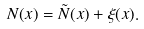Convert formula to latex. <formula><loc_0><loc_0><loc_500><loc_500>N ( x ) = \tilde { N } ( x ) + \xi ( x ) .</formula> 